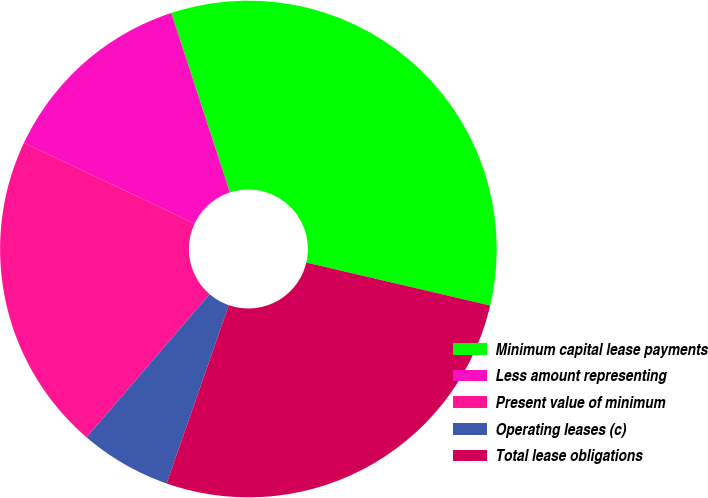Convert chart. <chart><loc_0><loc_0><loc_500><loc_500><pie_chart><fcel>Minimum capital lease payments<fcel>Less amount representing<fcel>Present value of minimum<fcel>Operating leases (c)<fcel>Total lease obligations<nl><fcel>33.68%<fcel>12.94%<fcel>20.74%<fcel>5.96%<fcel>26.69%<nl></chart> 